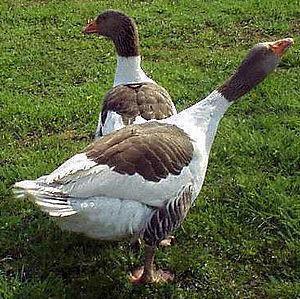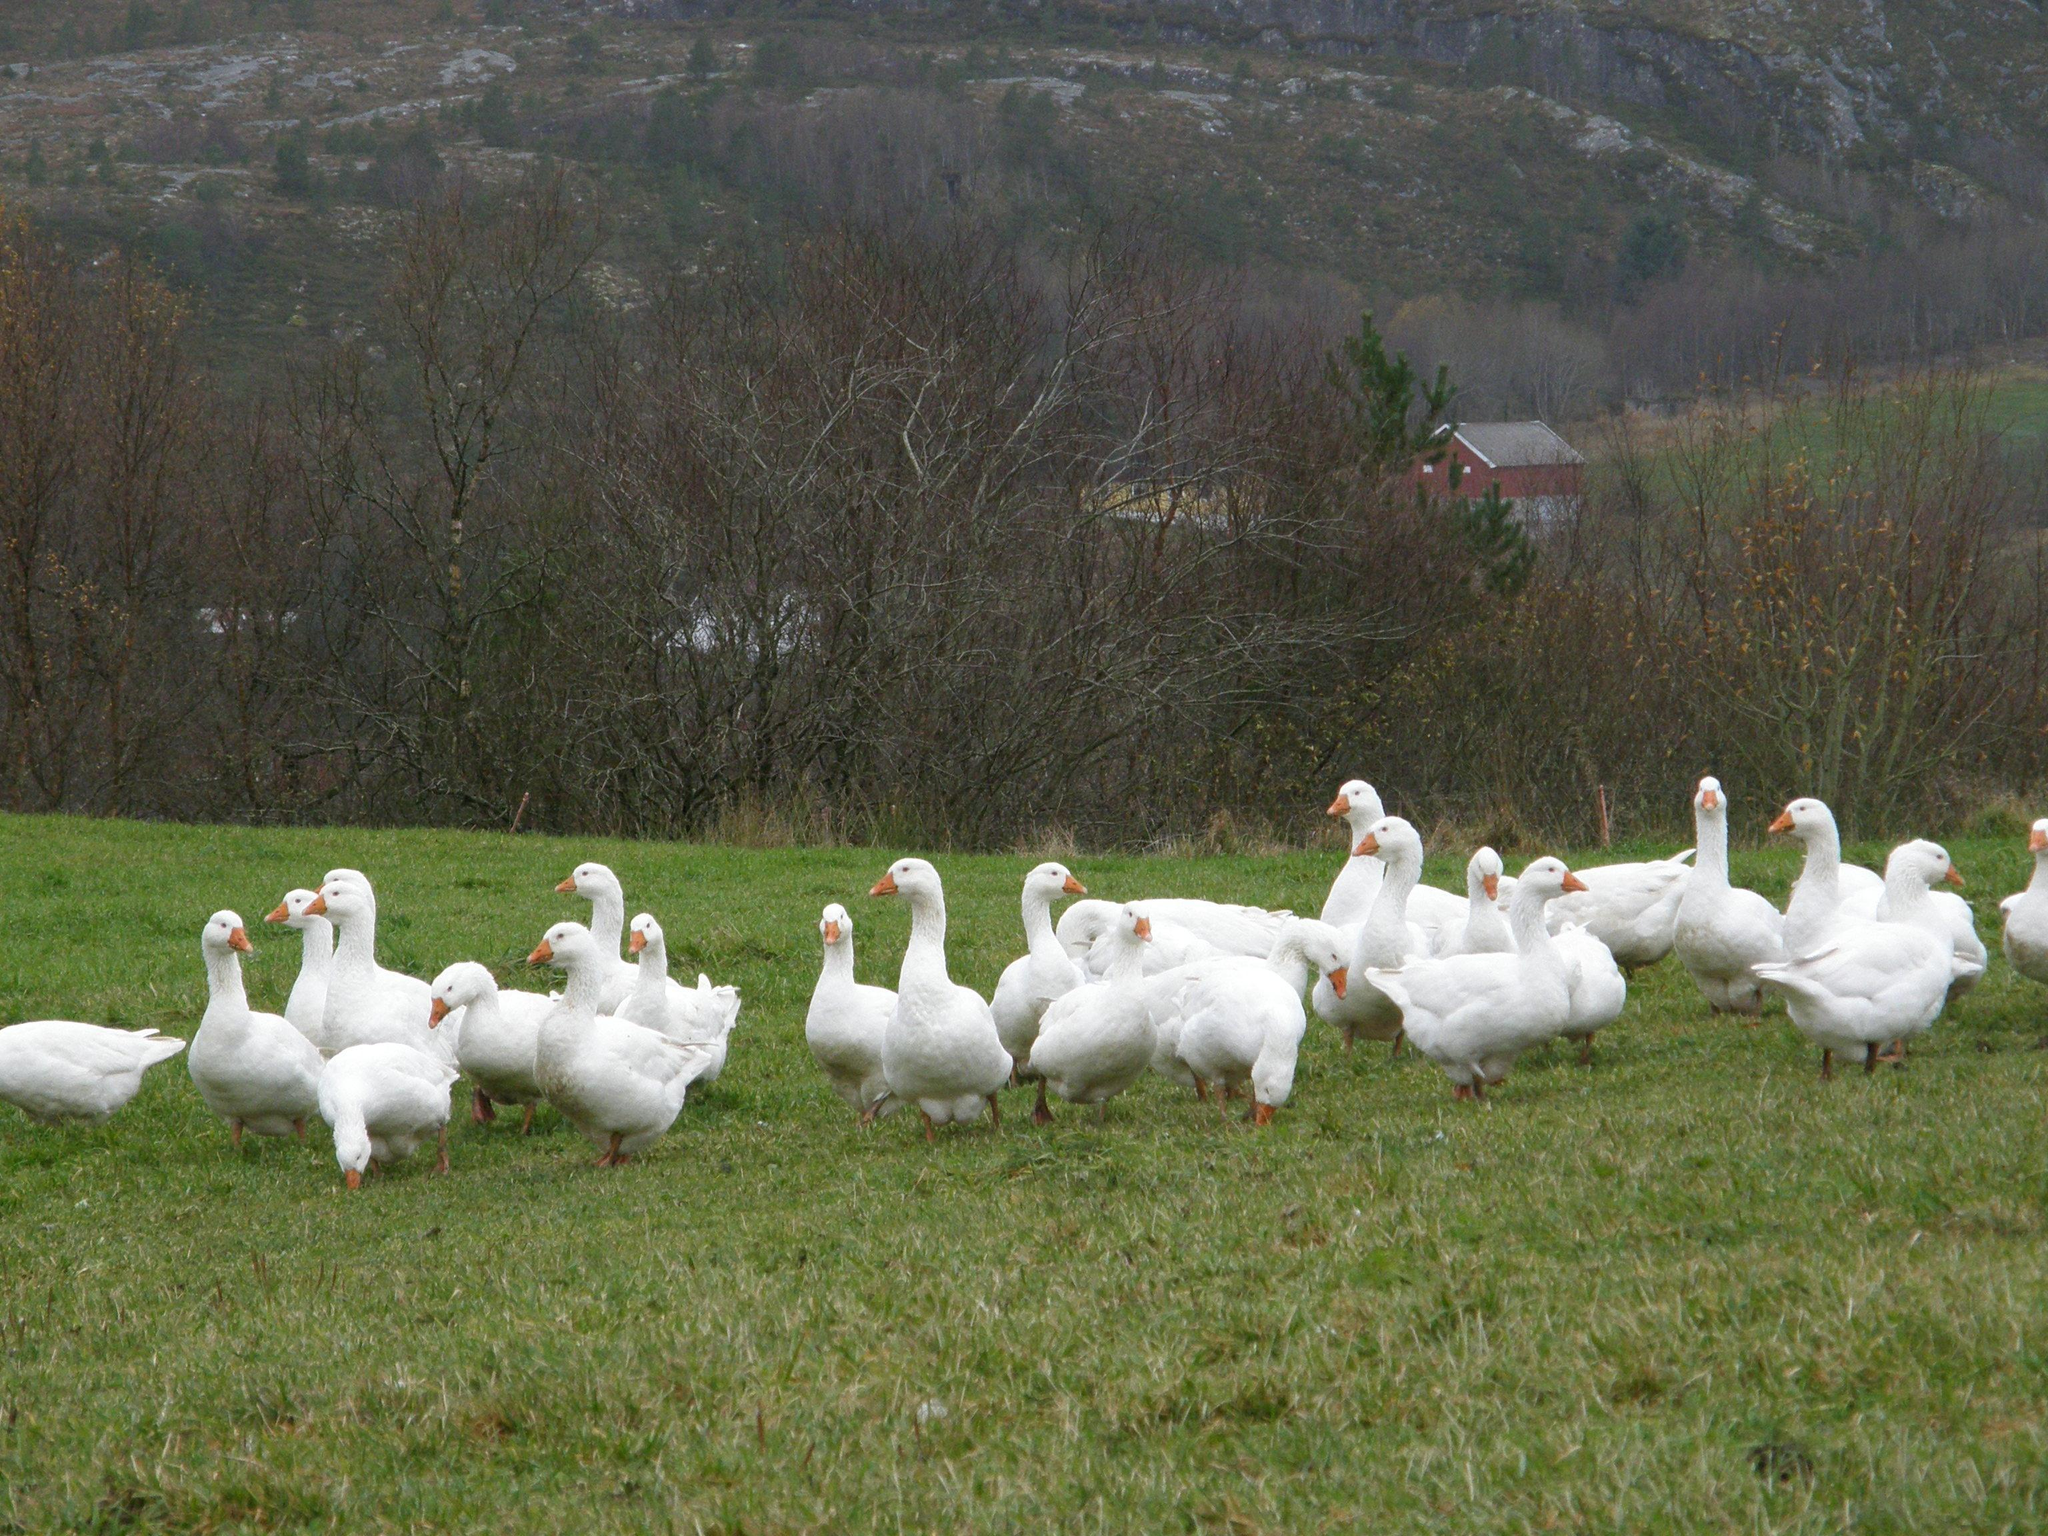The first image is the image on the left, the second image is the image on the right. Analyze the images presented: Is the assertion "The right image does not depict more geese than the left image." valid? Answer yes or no. No. 